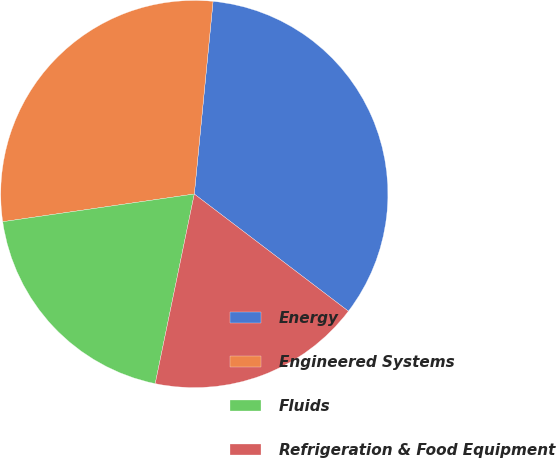Convert chart to OTSL. <chart><loc_0><loc_0><loc_500><loc_500><pie_chart><fcel>Energy<fcel>Engineered Systems<fcel>Fluids<fcel>Refrigeration & Food Equipment<nl><fcel>33.8%<fcel>28.83%<fcel>19.48%<fcel>17.89%<nl></chart> 